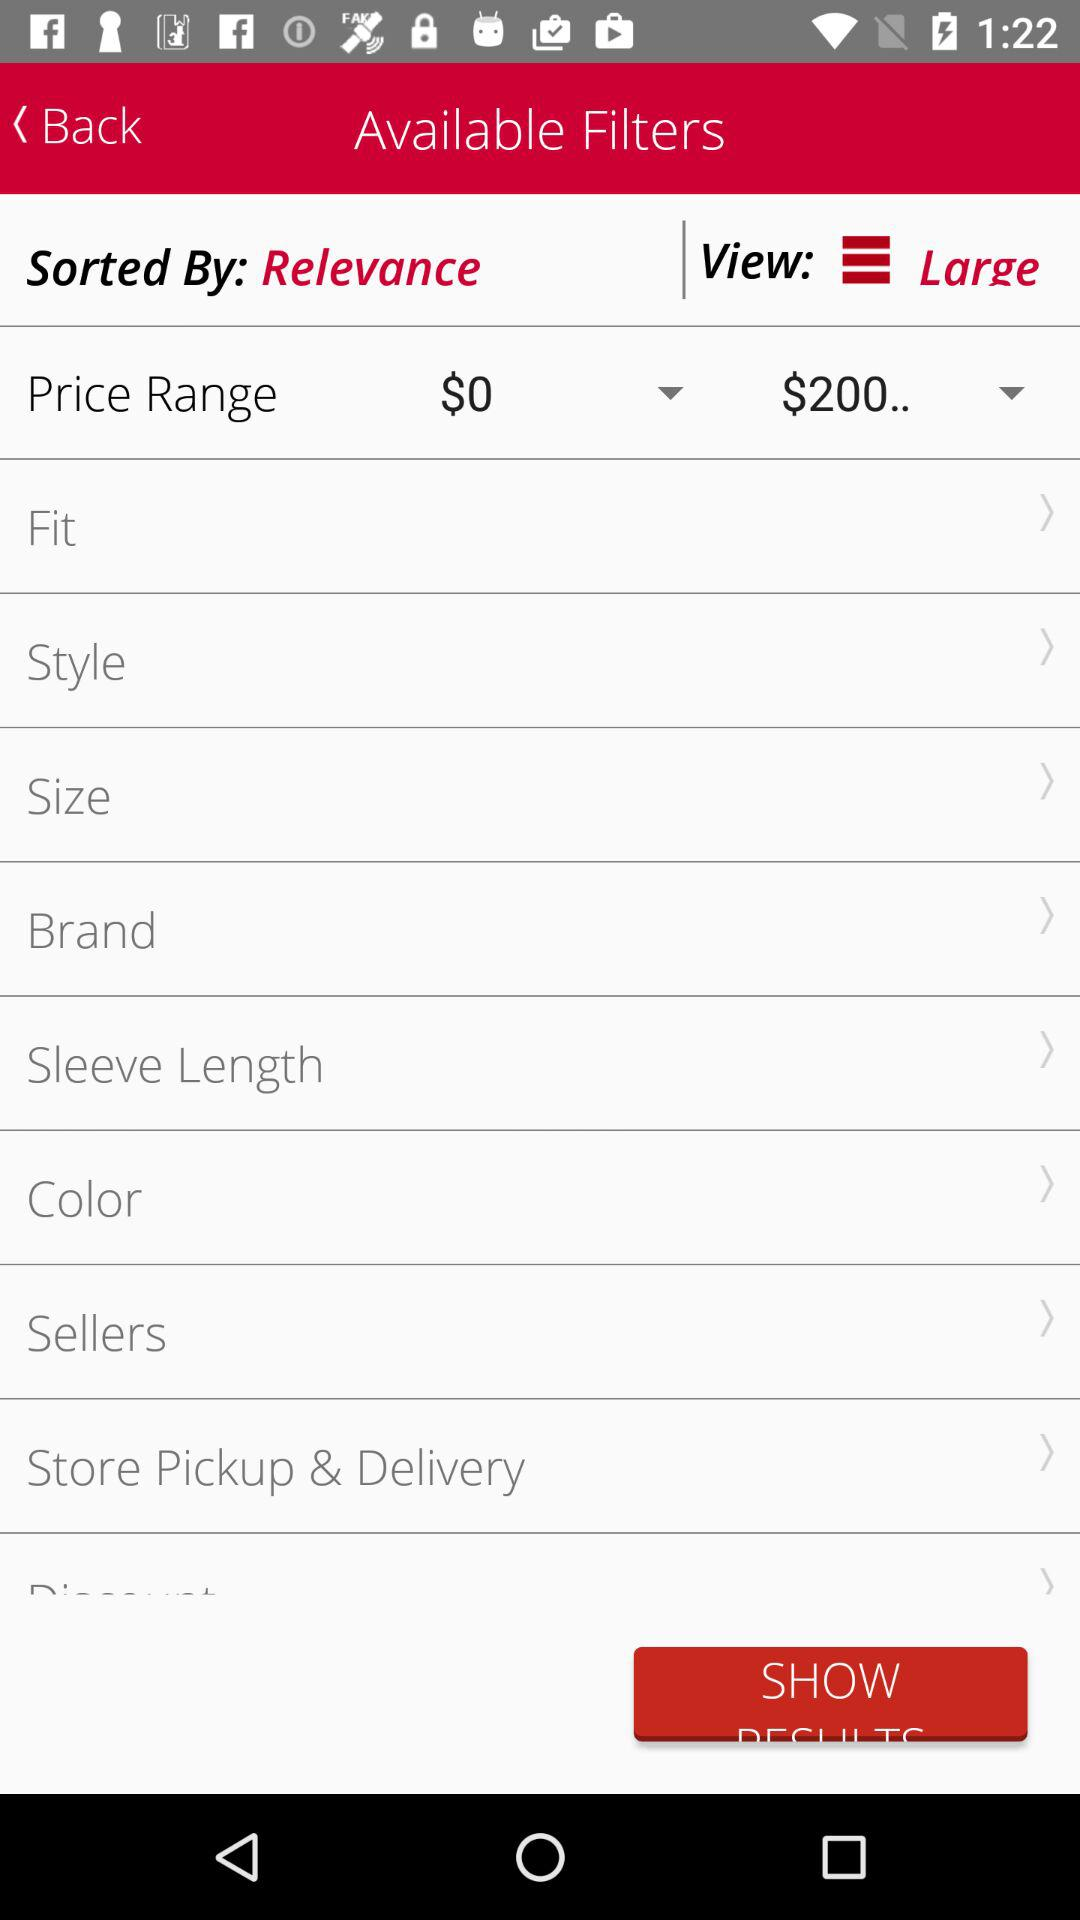What is the currency for the prices? The currency is $. 